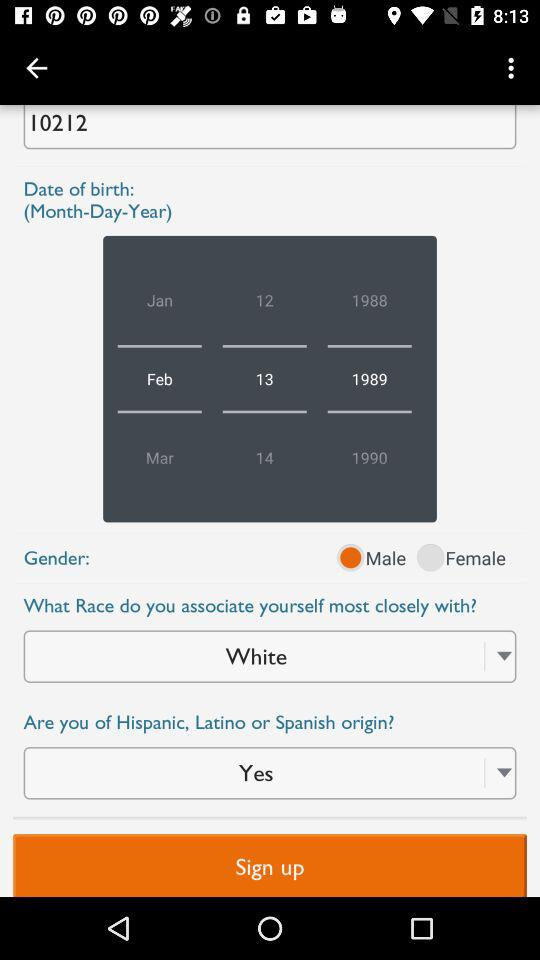What's the selected date? The selected date is February 13, 1989. 